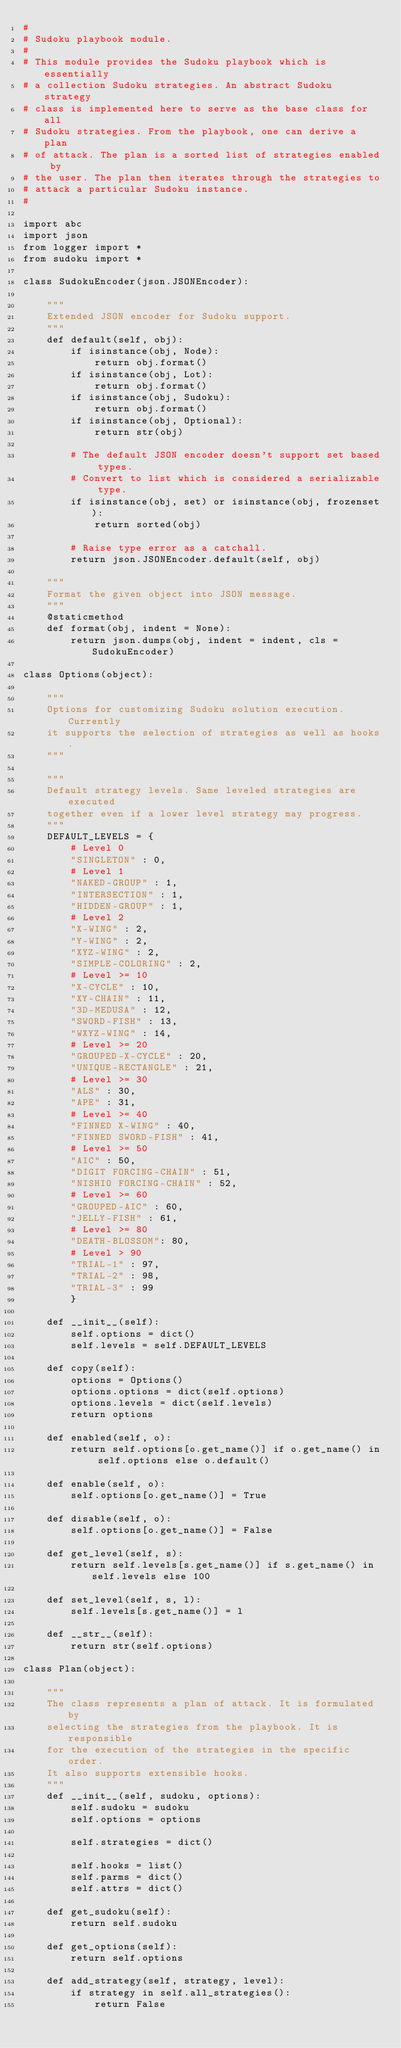<code> <loc_0><loc_0><loc_500><loc_500><_Python_>#
# Sudoku playbook module.
#
# This module provides the Sudoku playbook which is essentially
# a collection Sudoku strategies. An abstract Sudoku strategy
# class is implemented here to serve as the base class for all
# Sudoku strategies. From the playbook, one can derive a plan
# of attack. The plan is a sorted list of strategies enabled by
# the user. The plan then iterates through the strategies to
# attack a particular Sudoku instance.
#

import abc
import json
from logger import *
from sudoku import *

class SudokuEncoder(json.JSONEncoder):

    """
    Extended JSON encoder for Sudoku support.
    """
    def default(self, obj):
        if isinstance(obj, Node):
            return obj.format()
        if isinstance(obj, Lot):
            return obj.format()
        if isinstance(obj, Sudoku):
            return obj.format()
        if isinstance(obj, Optional):
            return str(obj)

        # The default JSON encoder doesn't support set based types.
        # Convert to list which is considered a serializable type.
        if isinstance(obj, set) or isinstance(obj, frozenset):
            return sorted(obj)

        # Raise type error as a catchall.
        return json.JSONEncoder.default(self, obj)

    """
    Format the given object into JSON message.
    """
    @staticmethod
    def format(obj, indent = None):
        return json.dumps(obj, indent = indent, cls = SudokuEncoder)

class Options(object):

    """
    Options for customizing Sudoku solution execution. Currently
    it supports the selection of strategies as well as hooks.
    """

    """
    Default strategy levels. Same leveled strategies are executed
    together even if a lower level strategy may progress.
    """
    DEFAULT_LEVELS = {
        # Level 0
        "SINGLETON" : 0,
        # Level 1
        "NAKED-GROUP" : 1,
        "INTERSECTION" : 1,
        "HIDDEN-GROUP" : 1,
        # Level 2
        "X-WING" : 2,
        "Y-WING" : 2,
        "XYZ-WING" : 2,
        "SIMPLE-COLORING" : 2,
        # Level >= 10
        "X-CYCLE" : 10,
        "XY-CHAIN" : 11,
        "3D-MEDUSA" : 12,
        "SWORD-FISH" : 13,
        "WXYZ-WING" : 14,
        # Level >= 20
        "GROUPED-X-CYCLE" : 20,
        "UNIQUE-RECTANGLE" : 21,
        # Level >= 30
        "ALS" : 30,
        "APE" : 31,
        # Level >= 40
        "FINNED X-WING" : 40,
        "FINNED SWORD-FISH" : 41,
        # Level >= 50
        "AIC" : 50,
        "DIGIT FORCING-CHAIN" : 51,
        "NISHIO FORCING-CHAIN" : 52,
        # Level >= 60
        "GROUPED-AIC" : 60,
        "JELLY-FISH" : 61,
        # Level >= 80
        "DEATH-BLOSSOM": 80,
        # Level > 90
        "TRIAL-1" : 97,
        "TRIAL-2" : 98,
        "TRIAL-3" : 99
        }

    def __init__(self):
        self.options = dict()
        self.levels = self.DEFAULT_LEVELS

    def copy(self):
        options = Options()
        options.options = dict(self.options)
        options.levels = dict(self.levels)
        return options

    def enabled(self, o):
        return self.options[o.get_name()] if o.get_name() in self.options else o.default()

    def enable(self, o):
        self.options[o.get_name()] = True

    def disable(self, o):
        self.options[o.get_name()] = False

    def get_level(self, s):
        return self.levels[s.get_name()] if s.get_name() in self.levels else 100

    def set_level(self, s, l):
        self.levels[s.get_name()] = l

    def __str__(self):
        return str(self.options)

class Plan(object):

    """
    The class represents a plan of attack. It is formulated by
    selecting the strategies from the playbook. It is responsible
    for the execution of the strategies in the specific order.
    It also supports extensible hooks.
    """
    def __init__(self, sudoku, options):
        self.sudoku = sudoku
        self.options = options

        self.strategies = dict()

        self.hooks = list()
        self.parms = dict()
        self.attrs = dict()

    def get_sudoku(self):
        return self.sudoku

    def get_options(self):
        return self.options

    def add_strategy(self, strategy, level):
        if strategy in self.all_strategies():
            return False</code> 